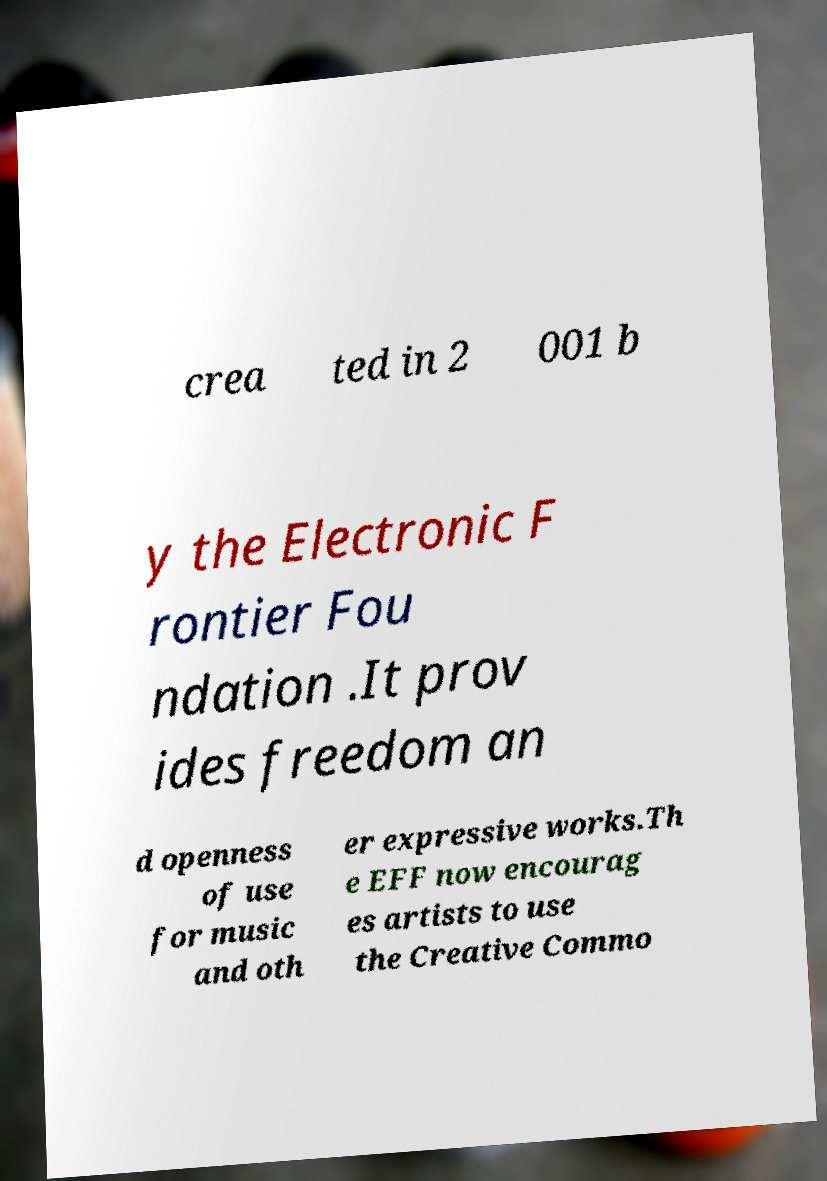I need the written content from this picture converted into text. Can you do that? crea ted in 2 001 b y the Electronic F rontier Fou ndation .It prov ides freedom an d openness of use for music and oth er expressive works.Th e EFF now encourag es artists to use the Creative Commo 